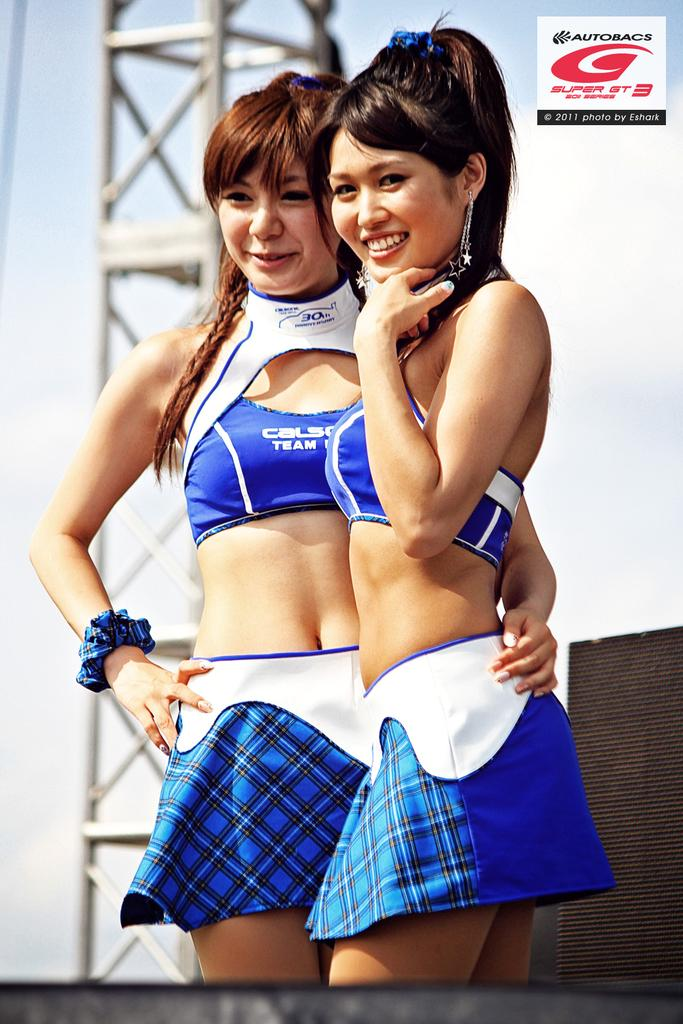<image>
Present a compact description of the photo's key features. Two women in skirts have tops that say Calsum team racing. 